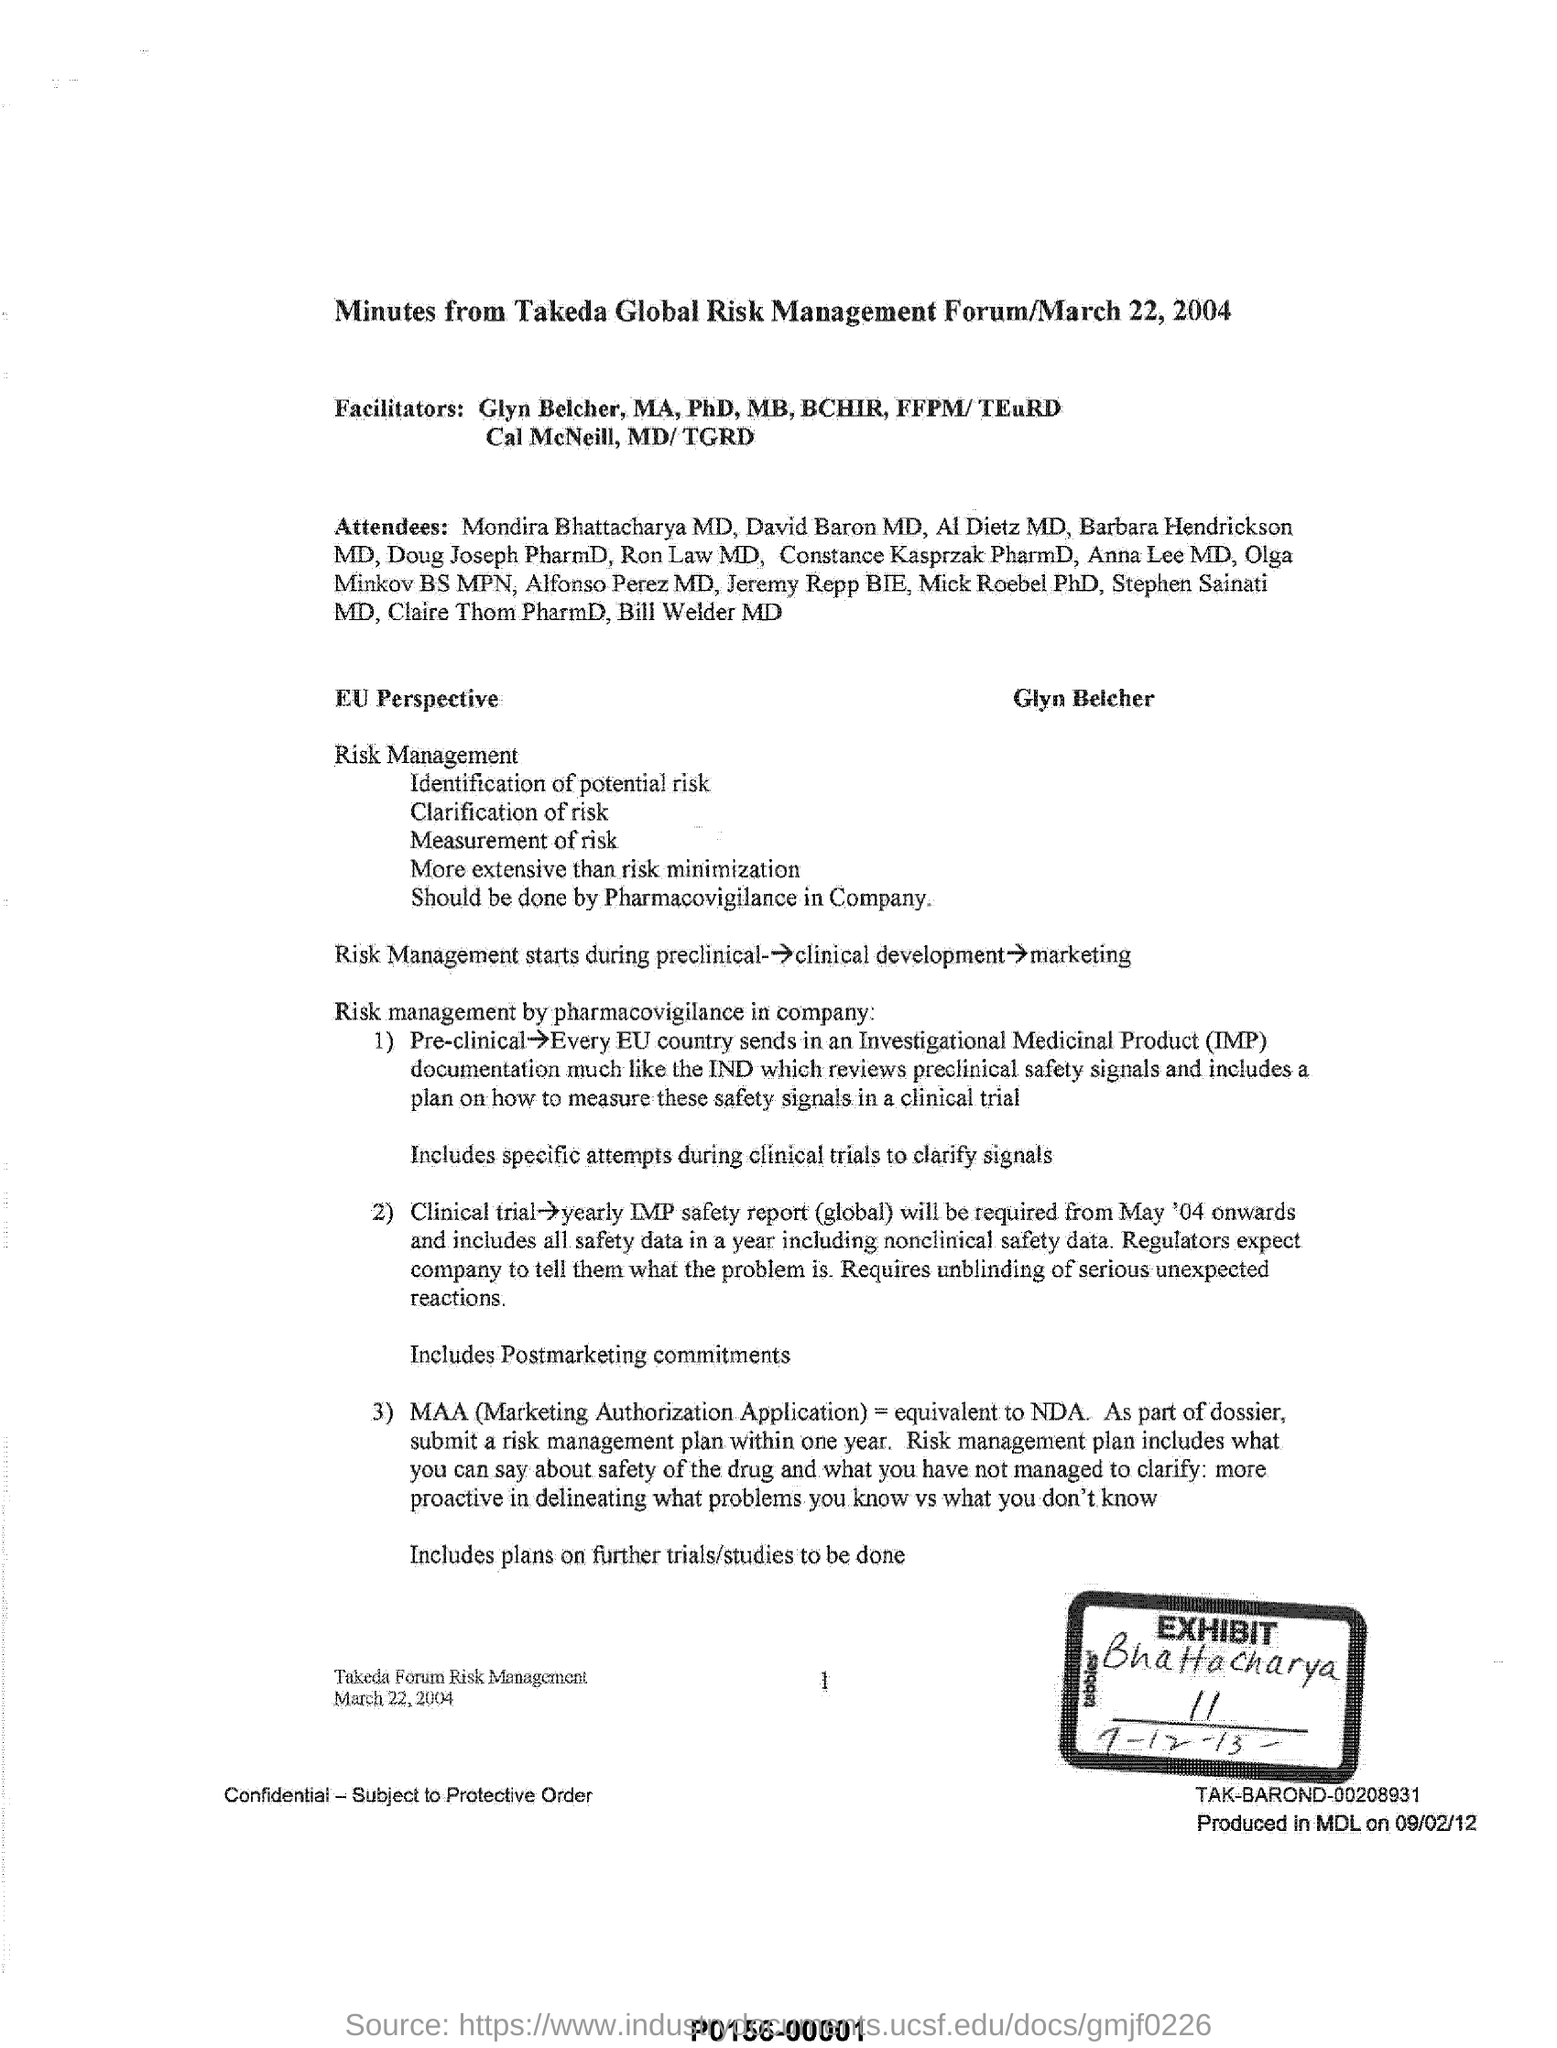What is the fullform of MAA?
Ensure brevity in your answer.  Marketing Authorization Application. Which forum is mentioned in this document?
Your answer should be very brief. Takeda Global Risk Management Forum. 